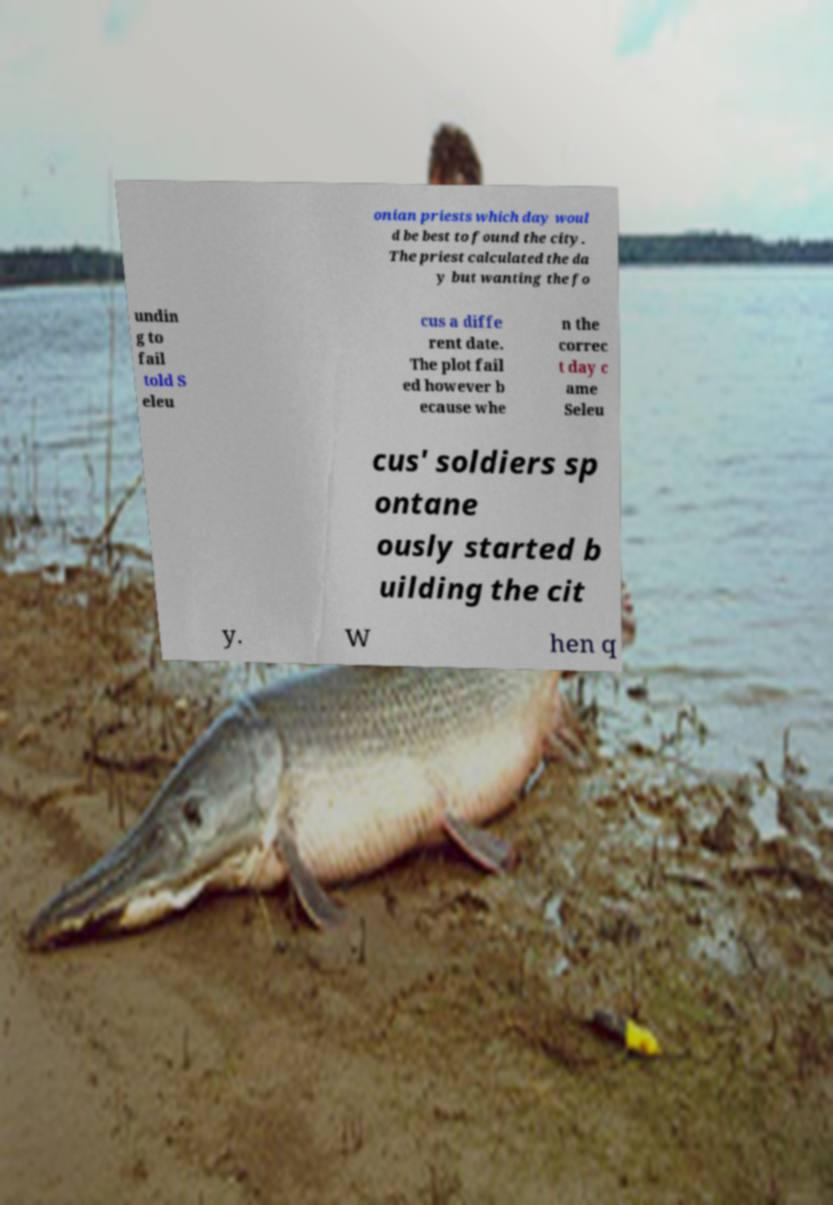Can you accurately transcribe the text from the provided image for me? onian priests which day woul d be best to found the city. The priest calculated the da y but wanting the fo undin g to fail told S eleu cus a diffe rent date. The plot fail ed however b ecause whe n the correc t day c ame Seleu cus' soldiers sp ontane ously started b uilding the cit y. W hen q 